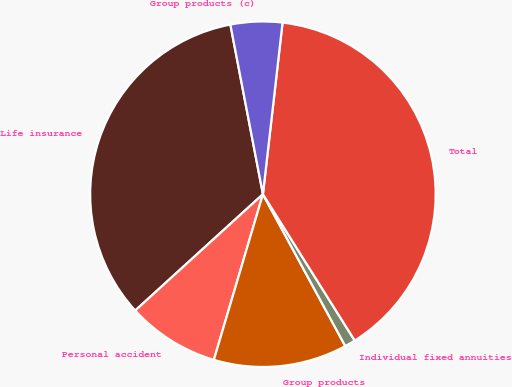Convert chart to OTSL. <chart><loc_0><loc_0><loc_500><loc_500><pie_chart><fcel>Life insurance<fcel>Personal accident<fcel>Group products<fcel>Individual fixed annuities<fcel>Total<fcel>Group products (c)<nl><fcel>33.74%<fcel>8.66%<fcel>12.49%<fcel>1.01%<fcel>39.27%<fcel>4.83%<nl></chart> 